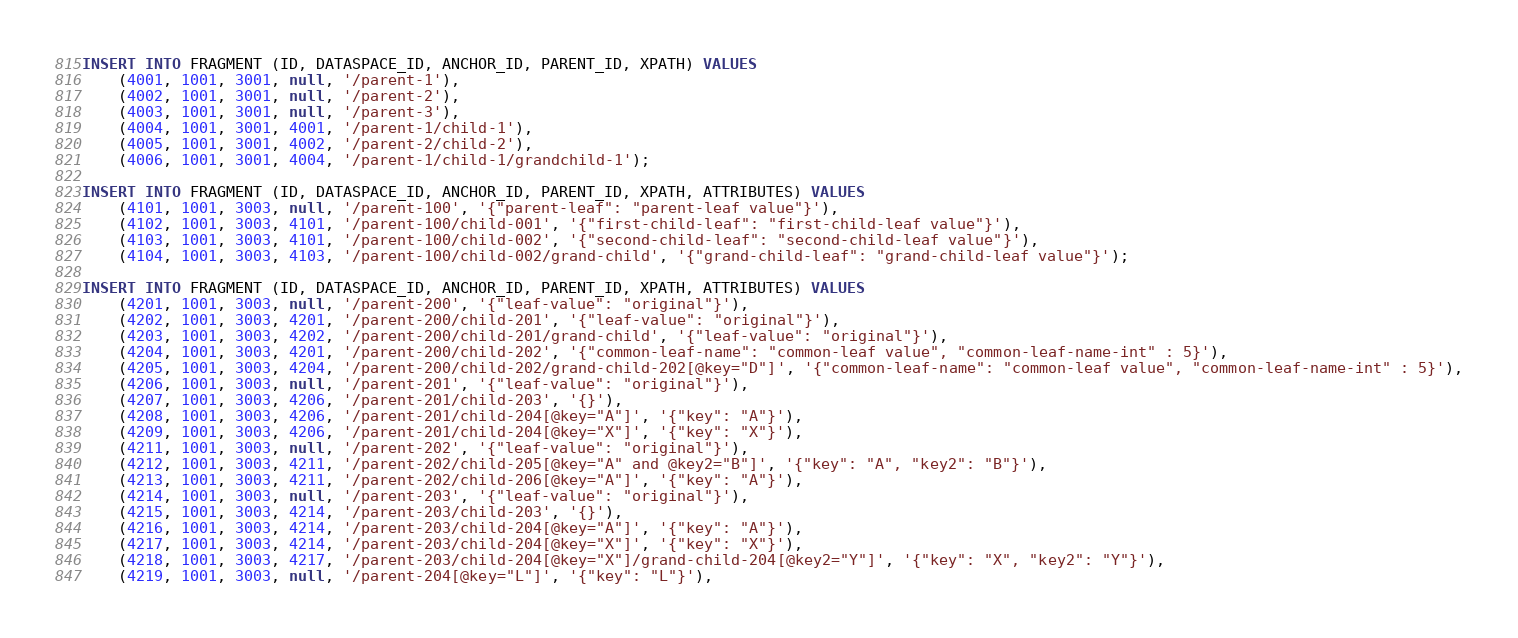Convert code to text. <code><loc_0><loc_0><loc_500><loc_500><_SQL_>
INSERT INTO FRAGMENT (ID, DATASPACE_ID, ANCHOR_ID, PARENT_ID, XPATH) VALUES
    (4001, 1001, 3001, null, '/parent-1'),
    (4002, 1001, 3001, null, '/parent-2'),
    (4003, 1001, 3001, null, '/parent-3'),
    (4004, 1001, 3001, 4001, '/parent-1/child-1'),
    (4005, 1001, 3001, 4002, '/parent-2/child-2'),
    (4006, 1001, 3001, 4004, '/parent-1/child-1/grandchild-1');

INSERT INTO FRAGMENT (ID, DATASPACE_ID, ANCHOR_ID, PARENT_ID, XPATH, ATTRIBUTES) VALUES
    (4101, 1001, 3003, null, '/parent-100', '{"parent-leaf": "parent-leaf value"}'),
    (4102, 1001, 3003, 4101, '/parent-100/child-001', '{"first-child-leaf": "first-child-leaf value"}'),
    (4103, 1001, 3003, 4101, '/parent-100/child-002', '{"second-child-leaf": "second-child-leaf value"}'),
    (4104, 1001, 3003, 4103, '/parent-100/child-002/grand-child', '{"grand-child-leaf": "grand-child-leaf value"}');

INSERT INTO FRAGMENT (ID, DATASPACE_ID, ANCHOR_ID, PARENT_ID, XPATH, ATTRIBUTES) VALUES
    (4201, 1001, 3003, null, '/parent-200', '{"leaf-value": "original"}'),
    (4202, 1001, 3003, 4201, '/parent-200/child-201', '{"leaf-value": "original"}'),
    (4203, 1001, 3003, 4202, '/parent-200/child-201/grand-child', '{"leaf-value": "original"}'),
    (4204, 1001, 3003, 4201, '/parent-200/child-202', '{"common-leaf-name": "common-leaf value", "common-leaf-name-int" : 5}'),
    (4205, 1001, 3003, 4204, '/parent-200/child-202/grand-child-202[@key="D"]', '{"common-leaf-name": "common-leaf value", "common-leaf-name-int" : 5}'),
    (4206, 1001, 3003, null, '/parent-201', '{"leaf-value": "original"}'),
    (4207, 1001, 3003, 4206, '/parent-201/child-203', '{}'),
    (4208, 1001, 3003, 4206, '/parent-201/child-204[@key="A"]', '{"key": "A"}'),
    (4209, 1001, 3003, 4206, '/parent-201/child-204[@key="X"]', '{"key": "X"}'),
    (4211, 1001, 3003, null, '/parent-202', '{"leaf-value": "original"}'),
    (4212, 1001, 3003, 4211, '/parent-202/child-205[@key="A" and @key2="B"]', '{"key": "A", "key2": "B"}'),
    (4213, 1001, 3003, 4211, '/parent-202/child-206[@key="A"]', '{"key": "A"}'),
    (4214, 1001, 3003, null, '/parent-203', '{"leaf-value": "original"}'),
    (4215, 1001, 3003, 4214, '/parent-203/child-203', '{}'),
    (4216, 1001, 3003, 4214, '/parent-203/child-204[@key="A"]', '{"key": "A"}'),
    (4217, 1001, 3003, 4214, '/parent-203/child-204[@key="X"]', '{"key": "X"}'),
    (4218, 1001, 3003, 4217, '/parent-203/child-204[@key="X"]/grand-child-204[@key2="Y"]', '{"key": "X", "key2": "Y"}'),
    (4219, 1001, 3003, null, '/parent-204[@key="L"]', '{"key": "L"}'),</code> 